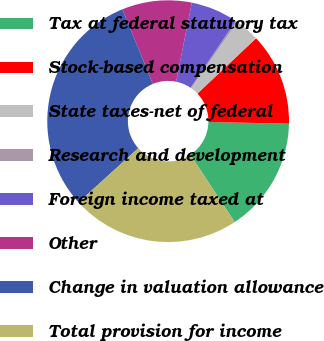Convert chart. <chart><loc_0><loc_0><loc_500><loc_500><pie_chart><fcel>Tax at federal statutory tax<fcel>Stock-based compensation<fcel>State taxes-net of federal<fcel>Research and development<fcel>Foreign income taxed at<fcel>Other<fcel>Change in valuation allowance<fcel>Total provision for income<nl><fcel>15.39%<fcel>12.36%<fcel>3.27%<fcel>0.25%<fcel>6.3%<fcel>9.33%<fcel>30.53%<fcel>22.56%<nl></chart> 